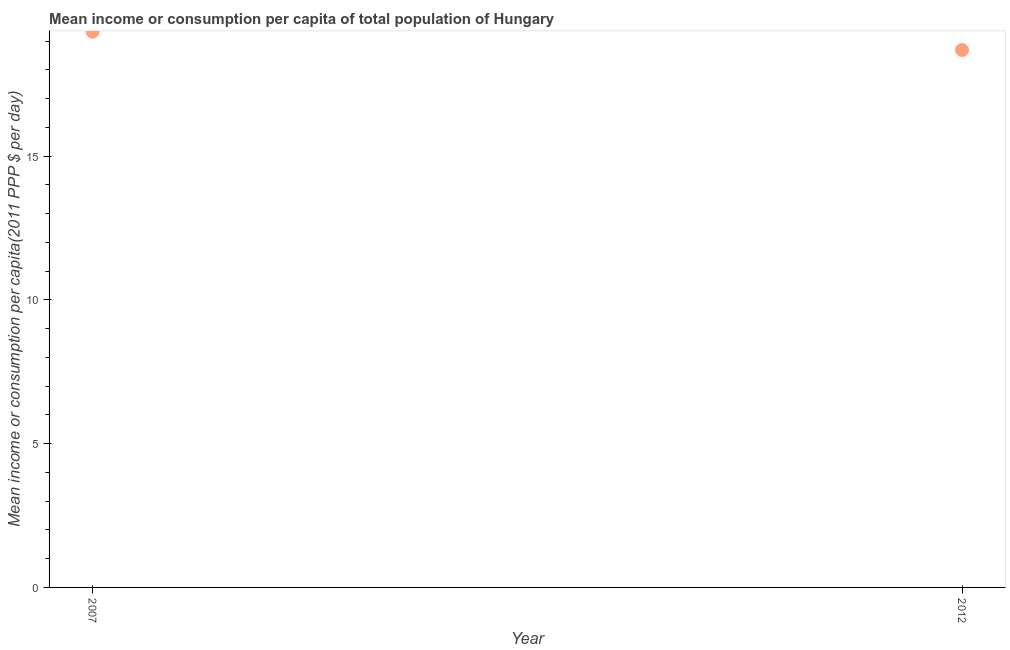What is the mean income or consumption in 2012?
Offer a very short reply. 18.69. Across all years, what is the maximum mean income or consumption?
Your response must be concise. 19.32. Across all years, what is the minimum mean income or consumption?
Provide a short and direct response. 18.69. In which year was the mean income or consumption maximum?
Provide a short and direct response. 2007. In which year was the mean income or consumption minimum?
Keep it short and to the point. 2012. What is the sum of the mean income or consumption?
Your response must be concise. 38.01. What is the difference between the mean income or consumption in 2007 and 2012?
Provide a short and direct response. 0.63. What is the average mean income or consumption per year?
Give a very brief answer. 19.01. What is the median mean income or consumption?
Your answer should be compact. 19.01. In how many years, is the mean income or consumption greater than 1 $?
Keep it short and to the point. 2. What is the ratio of the mean income or consumption in 2007 to that in 2012?
Ensure brevity in your answer.  1.03. Does the mean income or consumption monotonically increase over the years?
Ensure brevity in your answer.  No. How many years are there in the graph?
Ensure brevity in your answer.  2. What is the difference between two consecutive major ticks on the Y-axis?
Provide a short and direct response. 5. Does the graph contain any zero values?
Your answer should be very brief. No. Does the graph contain grids?
Make the answer very short. No. What is the title of the graph?
Your response must be concise. Mean income or consumption per capita of total population of Hungary. What is the label or title of the X-axis?
Provide a succinct answer. Year. What is the label or title of the Y-axis?
Give a very brief answer. Mean income or consumption per capita(2011 PPP $ per day). What is the Mean income or consumption per capita(2011 PPP $ per day) in 2007?
Offer a terse response. 19.32. What is the Mean income or consumption per capita(2011 PPP $ per day) in 2012?
Keep it short and to the point. 18.69. What is the difference between the Mean income or consumption per capita(2011 PPP $ per day) in 2007 and 2012?
Offer a very short reply. 0.63. What is the ratio of the Mean income or consumption per capita(2011 PPP $ per day) in 2007 to that in 2012?
Make the answer very short. 1.03. 